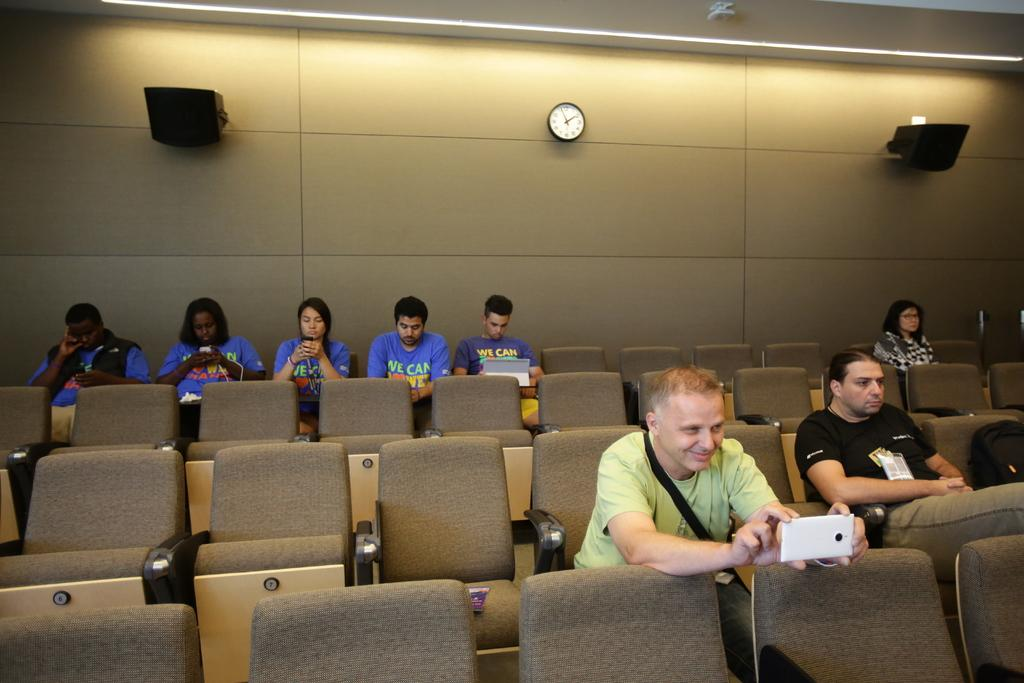<image>
Share a concise interpretation of the image provided. An auditorium with a few people sitting in it, some of whom are wearing shirts that read We Can. 